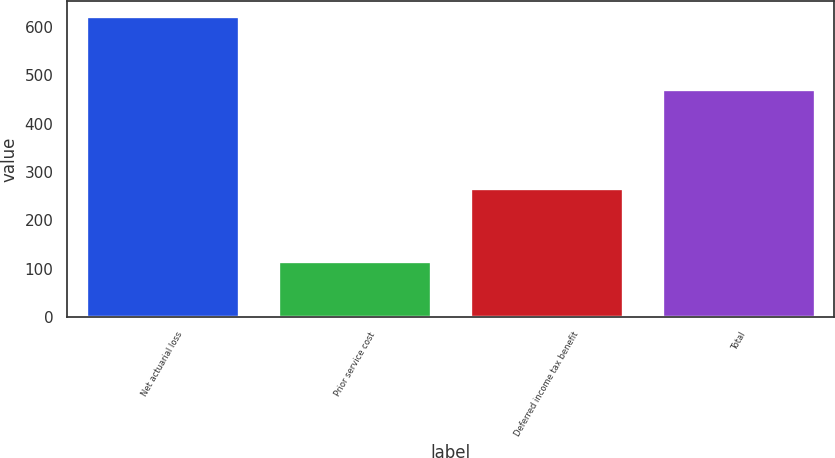<chart> <loc_0><loc_0><loc_500><loc_500><bar_chart><fcel>Net actuarial loss<fcel>Prior service cost<fcel>Deferred income tax benefit<fcel>Total<nl><fcel>622<fcel>116<fcel>267<fcel>471<nl></chart> 